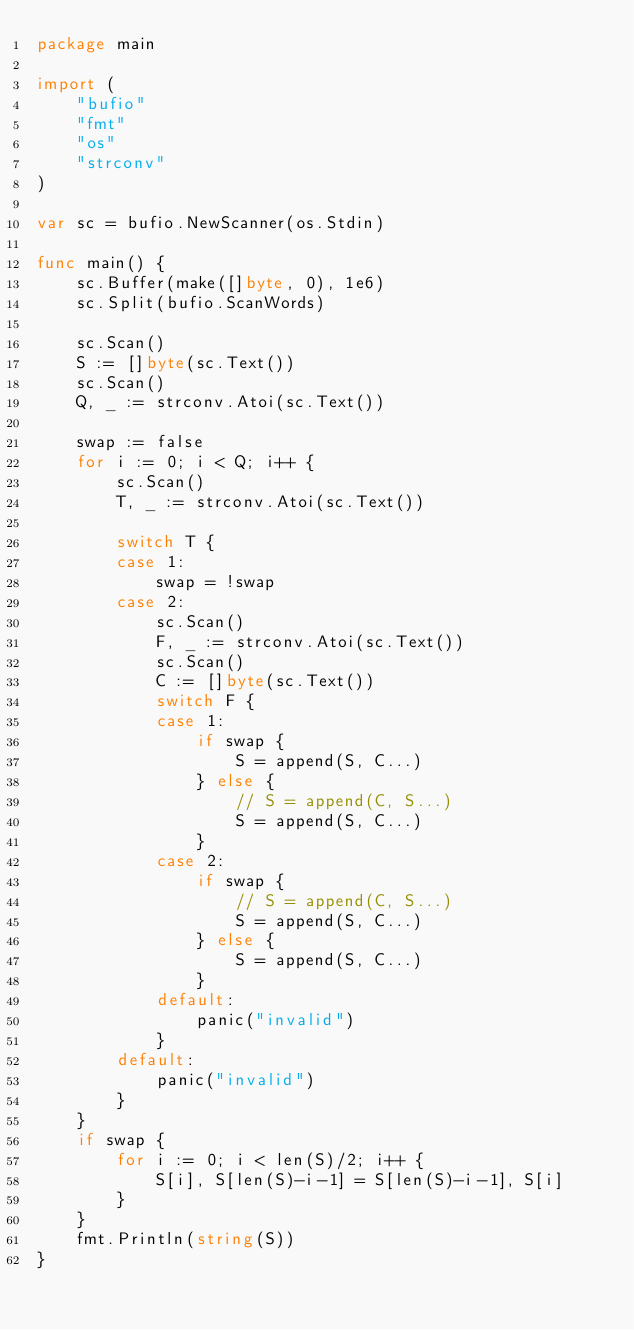Convert code to text. <code><loc_0><loc_0><loc_500><loc_500><_Go_>package main

import (
	"bufio"
	"fmt"
	"os"
	"strconv"
)

var sc = bufio.NewScanner(os.Stdin)

func main() {
	sc.Buffer(make([]byte, 0), 1e6)
	sc.Split(bufio.ScanWords)

	sc.Scan()
	S := []byte(sc.Text())
	sc.Scan()
	Q, _ := strconv.Atoi(sc.Text())

	swap := false
	for i := 0; i < Q; i++ {
		sc.Scan()
		T, _ := strconv.Atoi(sc.Text())

		switch T {
		case 1:
			swap = !swap
		case 2:
			sc.Scan()
			F, _ := strconv.Atoi(sc.Text())
			sc.Scan()
			C := []byte(sc.Text())
			switch F {
			case 1:
				if swap {
					S = append(S, C...)
				} else {
					// S = append(C, S...)
					S = append(S, C...)
				}
			case 2:
				if swap {
					// S = append(C, S...)
					S = append(S, C...)
				} else {
					S = append(S, C...)
				}
			default:
				panic("invalid")
			}
		default:
			panic("invalid")
		}
	}
	if swap {
		for i := 0; i < len(S)/2; i++ {
			S[i], S[len(S)-i-1] = S[len(S)-i-1], S[i]
		}
	}
	fmt.Println(string(S))
}
</code> 